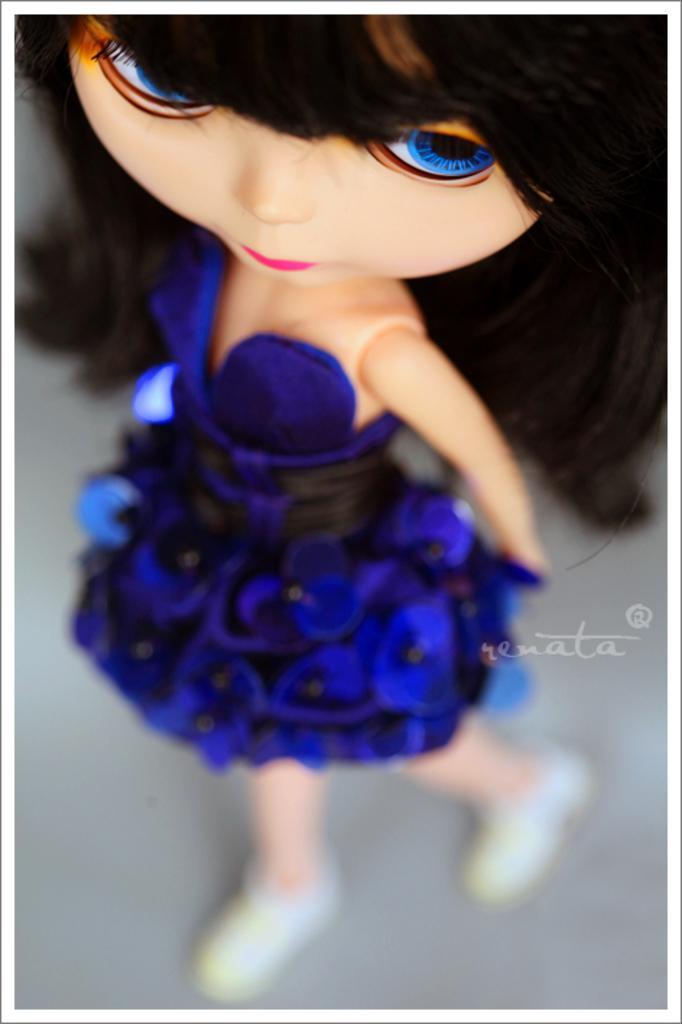Can you describe this image briefly? In this image, I can see a doll with blue color dress and shoes. I can see the watermark on the image. 